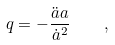<formula> <loc_0><loc_0><loc_500><loc_500>q = - \frac { \ddot { a } a } { \dot { a } ^ { 2 } } \quad ,</formula> 